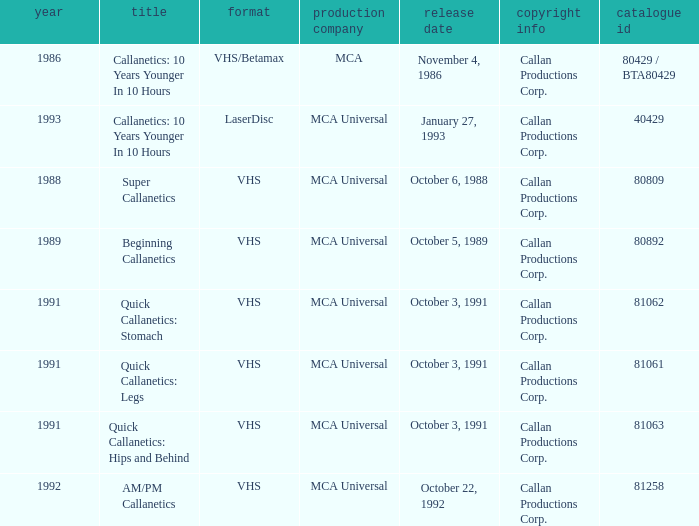Name the catalog number for  october 6, 1988 80809.0. 